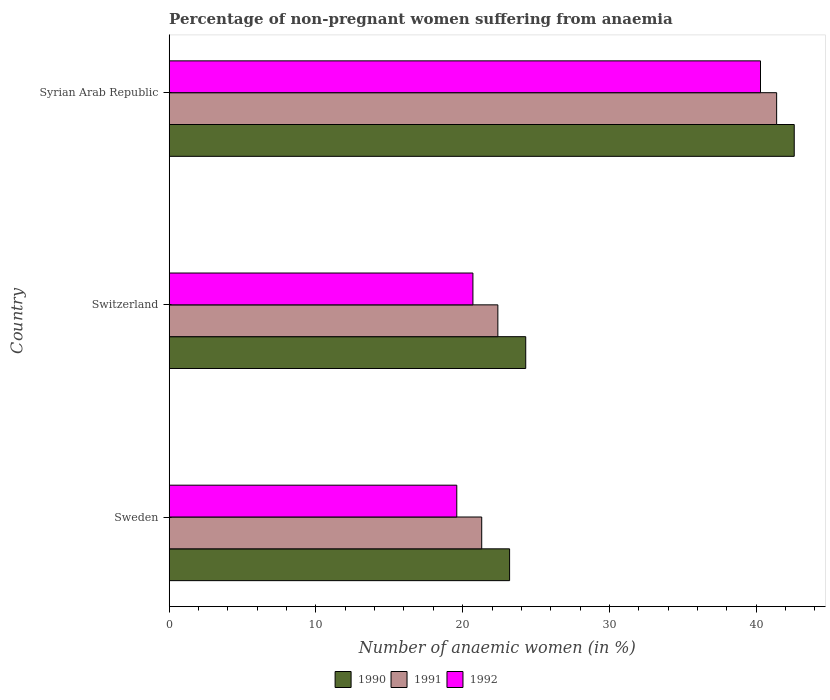Are the number of bars on each tick of the Y-axis equal?
Ensure brevity in your answer.  Yes. How many bars are there on the 2nd tick from the top?
Provide a short and direct response. 3. How many bars are there on the 1st tick from the bottom?
Your answer should be compact. 3. What is the label of the 2nd group of bars from the top?
Ensure brevity in your answer.  Switzerland. In how many cases, is the number of bars for a given country not equal to the number of legend labels?
Ensure brevity in your answer.  0. What is the percentage of non-pregnant women suffering from anaemia in 1991 in Switzerland?
Offer a terse response. 22.4. Across all countries, what is the maximum percentage of non-pregnant women suffering from anaemia in 1992?
Provide a short and direct response. 40.3. Across all countries, what is the minimum percentage of non-pregnant women suffering from anaemia in 1991?
Provide a succinct answer. 21.3. In which country was the percentage of non-pregnant women suffering from anaemia in 1990 maximum?
Offer a very short reply. Syrian Arab Republic. What is the total percentage of non-pregnant women suffering from anaemia in 1992 in the graph?
Your answer should be very brief. 80.6. What is the difference between the percentage of non-pregnant women suffering from anaemia in 1990 in Syrian Arab Republic and the percentage of non-pregnant women suffering from anaemia in 1992 in Switzerland?
Make the answer very short. 21.9. What is the average percentage of non-pregnant women suffering from anaemia in 1992 per country?
Your answer should be very brief. 26.87. What is the difference between the percentage of non-pregnant women suffering from anaemia in 1990 and percentage of non-pregnant women suffering from anaemia in 1991 in Switzerland?
Make the answer very short. 1.9. In how many countries, is the percentage of non-pregnant women suffering from anaemia in 1991 greater than 36 %?
Offer a terse response. 1. What is the ratio of the percentage of non-pregnant women suffering from anaemia in 1991 in Sweden to that in Syrian Arab Republic?
Offer a terse response. 0.51. Is the difference between the percentage of non-pregnant women suffering from anaemia in 1990 in Sweden and Switzerland greater than the difference between the percentage of non-pregnant women suffering from anaemia in 1991 in Sweden and Switzerland?
Give a very brief answer. No. What is the difference between the highest and the second highest percentage of non-pregnant women suffering from anaemia in 1991?
Make the answer very short. 19. What is the difference between the highest and the lowest percentage of non-pregnant women suffering from anaemia in 1992?
Make the answer very short. 20.7. In how many countries, is the percentage of non-pregnant women suffering from anaemia in 1990 greater than the average percentage of non-pregnant women suffering from anaemia in 1990 taken over all countries?
Provide a short and direct response. 1. Is the sum of the percentage of non-pregnant women suffering from anaemia in 1991 in Switzerland and Syrian Arab Republic greater than the maximum percentage of non-pregnant women suffering from anaemia in 1992 across all countries?
Your response must be concise. Yes. What does the 1st bar from the top in Switzerland represents?
Offer a very short reply. 1992. What does the 2nd bar from the bottom in Sweden represents?
Offer a terse response. 1991. Is it the case that in every country, the sum of the percentage of non-pregnant women suffering from anaemia in 1991 and percentage of non-pregnant women suffering from anaemia in 1990 is greater than the percentage of non-pregnant women suffering from anaemia in 1992?
Offer a very short reply. Yes. How many bars are there?
Your response must be concise. 9. Are all the bars in the graph horizontal?
Offer a very short reply. Yes. Does the graph contain any zero values?
Your response must be concise. No. Does the graph contain grids?
Provide a short and direct response. No. How many legend labels are there?
Your answer should be very brief. 3. How are the legend labels stacked?
Make the answer very short. Horizontal. What is the title of the graph?
Provide a succinct answer. Percentage of non-pregnant women suffering from anaemia. What is the label or title of the X-axis?
Keep it short and to the point. Number of anaemic women (in %). What is the Number of anaemic women (in %) of 1990 in Sweden?
Keep it short and to the point. 23.2. What is the Number of anaemic women (in %) in 1991 in Sweden?
Provide a succinct answer. 21.3. What is the Number of anaemic women (in %) of 1992 in Sweden?
Offer a terse response. 19.6. What is the Number of anaemic women (in %) in 1990 in Switzerland?
Your response must be concise. 24.3. What is the Number of anaemic women (in %) of 1991 in Switzerland?
Your answer should be compact. 22.4. What is the Number of anaemic women (in %) of 1992 in Switzerland?
Make the answer very short. 20.7. What is the Number of anaemic women (in %) in 1990 in Syrian Arab Republic?
Provide a succinct answer. 42.6. What is the Number of anaemic women (in %) in 1991 in Syrian Arab Republic?
Your answer should be compact. 41.4. What is the Number of anaemic women (in %) of 1992 in Syrian Arab Republic?
Offer a terse response. 40.3. Across all countries, what is the maximum Number of anaemic women (in %) of 1990?
Give a very brief answer. 42.6. Across all countries, what is the maximum Number of anaemic women (in %) of 1991?
Ensure brevity in your answer.  41.4. Across all countries, what is the maximum Number of anaemic women (in %) in 1992?
Offer a very short reply. 40.3. Across all countries, what is the minimum Number of anaemic women (in %) in 1990?
Provide a succinct answer. 23.2. Across all countries, what is the minimum Number of anaemic women (in %) in 1991?
Offer a very short reply. 21.3. Across all countries, what is the minimum Number of anaemic women (in %) of 1992?
Ensure brevity in your answer.  19.6. What is the total Number of anaemic women (in %) in 1990 in the graph?
Give a very brief answer. 90.1. What is the total Number of anaemic women (in %) of 1991 in the graph?
Ensure brevity in your answer.  85.1. What is the total Number of anaemic women (in %) in 1992 in the graph?
Ensure brevity in your answer.  80.6. What is the difference between the Number of anaemic women (in %) in 1990 in Sweden and that in Syrian Arab Republic?
Keep it short and to the point. -19.4. What is the difference between the Number of anaemic women (in %) in 1991 in Sweden and that in Syrian Arab Republic?
Your response must be concise. -20.1. What is the difference between the Number of anaemic women (in %) in 1992 in Sweden and that in Syrian Arab Republic?
Keep it short and to the point. -20.7. What is the difference between the Number of anaemic women (in %) of 1990 in Switzerland and that in Syrian Arab Republic?
Make the answer very short. -18.3. What is the difference between the Number of anaemic women (in %) in 1992 in Switzerland and that in Syrian Arab Republic?
Your response must be concise. -19.6. What is the difference between the Number of anaemic women (in %) of 1990 in Sweden and the Number of anaemic women (in %) of 1991 in Switzerland?
Your answer should be compact. 0.8. What is the difference between the Number of anaemic women (in %) in 1990 in Sweden and the Number of anaemic women (in %) in 1992 in Switzerland?
Ensure brevity in your answer.  2.5. What is the difference between the Number of anaemic women (in %) of 1990 in Sweden and the Number of anaemic women (in %) of 1991 in Syrian Arab Republic?
Provide a succinct answer. -18.2. What is the difference between the Number of anaemic women (in %) in 1990 in Sweden and the Number of anaemic women (in %) in 1992 in Syrian Arab Republic?
Your response must be concise. -17.1. What is the difference between the Number of anaemic women (in %) in 1990 in Switzerland and the Number of anaemic women (in %) in 1991 in Syrian Arab Republic?
Offer a terse response. -17.1. What is the difference between the Number of anaemic women (in %) of 1991 in Switzerland and the Number of anaemic women (in %) of 1992 in Syrian Arab Republic?
Provide a succinct answer. -17.9. What is the average Number of anaemic women (in %) in 1990 per country?
Provide a short and direct response. 30.03. What is the average Number of anaemic women (in %) in 1991 per country?
Make the answer very short. 28.37. What is the average Number of anaemic women (in %) in 1992 per country?
Offer a terse response. 26.87. What is the difference between the Number of anaemic women (in %) in 1990 and Number of anaemic women (in %) in 1991 in Sweden?
Your answer should be very brief. 1.9. What is the difference between the Number of anaemic women (in %) of 1990 and Number of anaemic women (in %) of 1991 in Switzerland?
Keep it short and to the point. 1.9. What is the difference between the Number of anaemic women (in %) of 1990 and Number of anaemic women (in %) of 1992 in Switzerland?
Make the answer very short. 3.6. What is the difference between the Number of anaemic women (in %) of 1991 and Number of anaemic women (in %) of 1992 in Switzerland?
Ensure brevity in your answer.  1.7. What is the ratio of the Number of anaemic women (in %) of 1990 in Sweden to that in Switzerland?
Make the answer very short. 0.95. What is the ratio of the Number of anaemic women (in %) of 1991 in Sweden to that in Switzerland?
Ensure brevity in your answer.  0.95. What is the ratio of the Number of anaemic women (in %) in 1992 in Sweden to that in Switzerland?
Give a very brief answer. 0.95. What is the ratio of the Number of anaemic women (in %) of 1990 in Sweden to that in Syrian Arab Republic?
Your response must be concise. 0.54. What is the ratio of the Number of anaemic women (in %) in 1991 in Sweden to that in Syrian Arab Republic?
Ensure brevity in your answer.  0.51. What is the ratio of the Number of anaemic women (in %) of 1992 in Sweden to that in Syrian Arab Republic?
Ensure brevity in your answer.  0.49. What is the ratio of the Number of anaemic women (in %) in 1990 in Switzerland to that in Syrian Arab Republic?
Your response must be concise. 0.57. What is the ratio of the Number of anaemic women (in %) in 1991 in Switzerland to that in Syrian Arab Republic?
Provide a succinct answer. 0.54. What is the ratio of the Number of anaemic women (in %) of 1992 in Switzerland to that in Syrian Arab Republic?
Your answer should be compact. 0.51. What is the difference between the highest and the second highest Number of anaemic women (in %) of 1992?
Provide a short and direct response. 19.6. What is the difference between the highest and the lowest Number of anaemic women (in %) in 1990?
Your answer should be compact. 19.4. What is the difference between the highest and the lowest Number of anaemic women (in %) in 1991?
Keep it short and to the point. 20.1. What is the difference between the highest and the lowest Number of anaemic women (in %) of 1992?
Give a very brief answer. 20.7. 